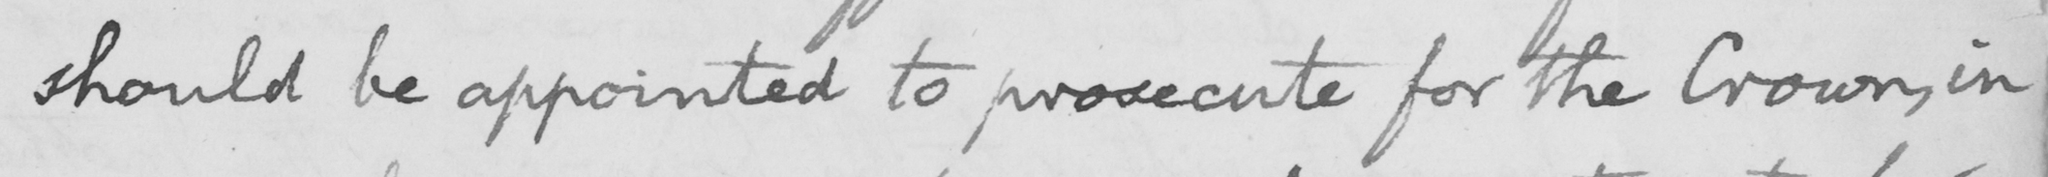Can you read and transcribe this handwriting? should be appointed to prosecute for the Crown, in 